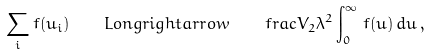<formula> <loc_0><loc_0><loc_500><loc_500>\sum _ { i } f ( u _ { i } ) \quad L o n g r i g h t a r r o w \quad f r a c { V _ { 2 } } { \lambda ^ { 2 } } \int _ { 0 } ^ { \infty } \, f ( u ) \, d u \, ,</formula> 